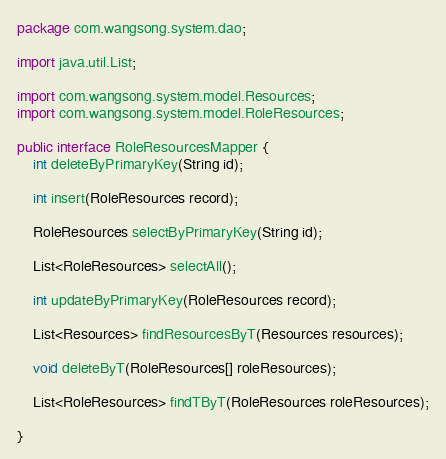<code> <loc_0><loc_0><loc_500><loc_500><_Java_>package com.wangsong.system.dao;

import java.util.List;

import com.wangsong.system.model.Resources;
import com.wangsong.system.model.RoleResources;

public interface RoleResourcesMapper {
	int deleteByPrimaryKey(String id);

    int insert(RoleResources record);

    RoleResources selectByPrimaryKey(String id);

    List<RoleResources> selectAll();

    int updateByPrimaryKey(RoleResources record);
    
	List<Resources> findResourcesByT(Resources resources);

	void deleteByT(RoleResources[] roleResources);

	List<RoleResources> findTByT(RoleResources roleResources);
		
}</code> 